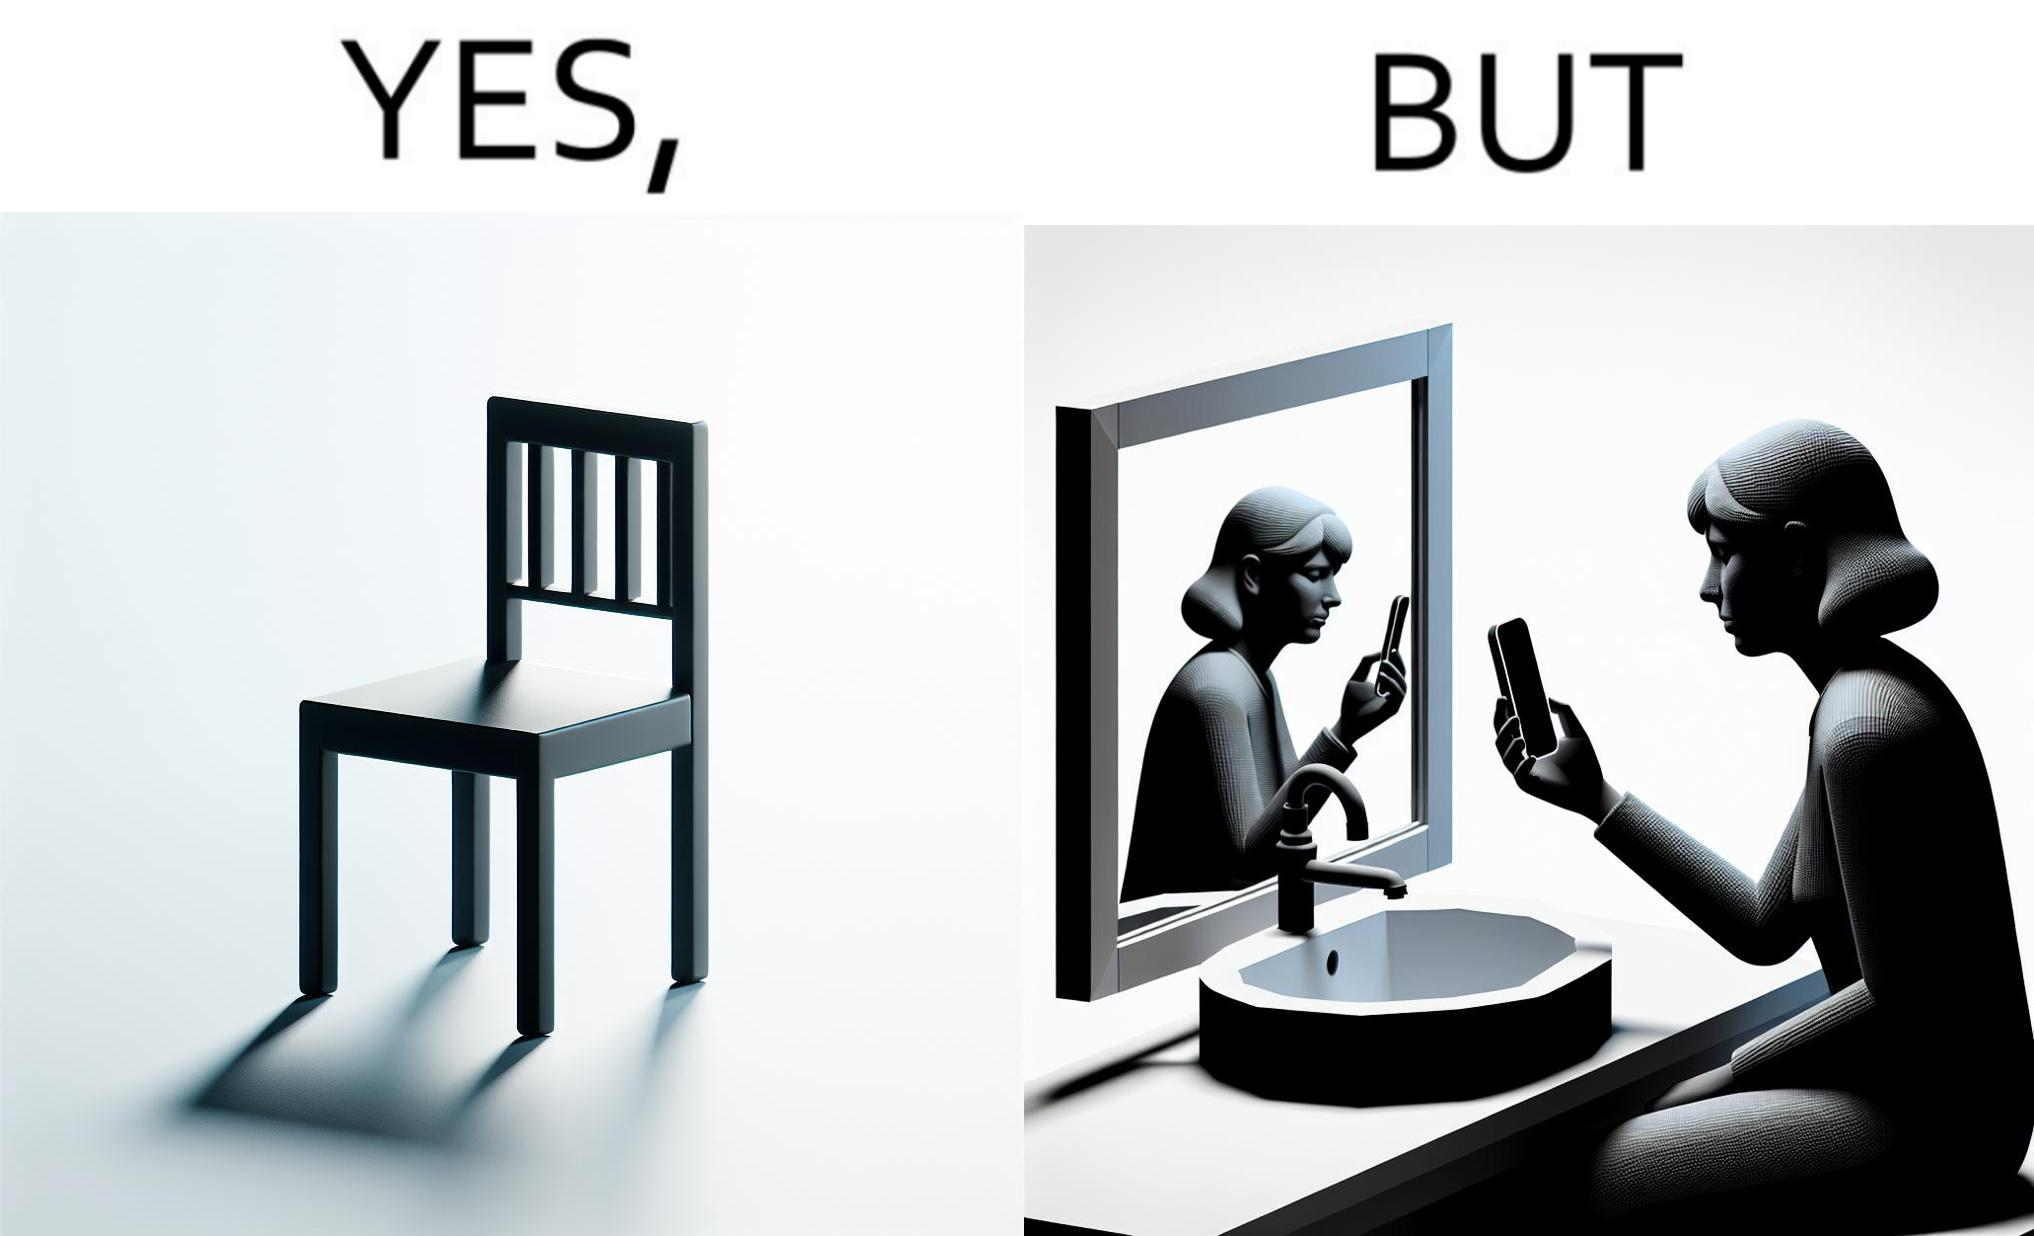Would you classify this image as satirical? Yes, this image is satirical. 